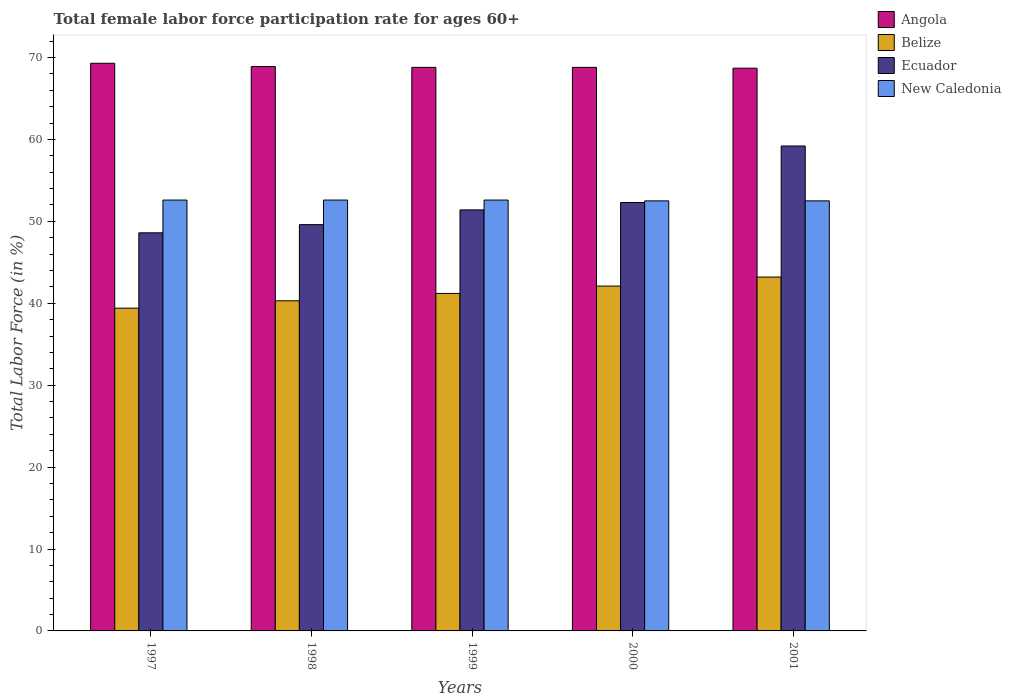How many different coloured bars are there?
Your response must be concise. 4. What is the label of the 1st group of bars from the left?
Your response must be concise. 1997. In how many cases, is the number of bars for a given year not equal to the number of legend labels?
Your answer should be compact. 0. What is the female labor force participation rate in Angola in 1999?
Offer a very short reply. 68.8. Across all years, what is the maximum female labor force participation rate in New Caledonia?
Your response must be concise. 52.6. Across all years, what is the minimum female labor force participation rate in Belize?
Provide a short and direct response. 39.4. In which year was the female labor force participation rate in Belize maximum?
Offer a terse response. 2001. What is the total female labor force participation rate in Angola in the graph?
Make the answer very short. 344.5. What is the difference between the female labor force participation rate in Belize in 1997 and that in 2000?
Ensure brevity in your answer.  -2.7. What is the difference between the female labor force participation rate in Ecuador in 2000 and the female labor force participation rate in Belize in 1999?
Provide a short and direct response. 11.1. What is the average female labor force participation rate in New Caledonia per year?
Make the answer very short. 52.56. In the year 2000, what is the difference between the female labor force participation rate in Belize and female labor force participation rate in Angola?
Make the answer very short. -26.7. What is the ratio of the female labor force participation rate in New Caledonia in 1997 to that in 2001?
Provide a short and direct response. 1. Is the female labor force participation rate in Ecuador in 1998 less than that in 2000?
Offer a very short reply. Yes. What is the difference between the highest and the second highest female labor force participation rate in Ecuador?
Provide a succinct answer. 6.9. What is the difference between the highest and the lowest female labor force participation rate in Ecuador?
Provide a succinct answer. 10.6. Is the sum of the female labor force participation rate in Belize in 1998 and 1999 greater than the maximum female labor force participation rate in New Caledonia across all years?
Give a very brief answer. Yes. Is it the case that in every year, the sum of the female labor force participation rate in Belize and female labor force participation rate in New Caledonia is greater than the sum of female labor force participation rate in Ecuador and female labor force participation rate in Angola?
Give a very brief answer. No. What does the 4th bar from the left in 1999 represents?
Offer a terse response. New Caledonia. What does the 3rd bar from the right in 1997 represents?
Offer a very short reply. Belize. Is it the case that in every year, the sum of the female labor force participation rate in Ecuador and female labor force participation rate in New Caledonia is greater than the female labor force participation rate in Angola?
Provide a short and direct response. Yes. Are all the bars in the graph horizontal?
Offer a terse response. No. How many years are there in the graph?
Your answer should be very brief. 5. Are the values on the major ticks of Y-axis written in scientific E-notation?
Provide a succinct answer. No. Does the graph contain grids?
Your answer should be very brief. No. How many legend labels are there?
Make the answer very short. 4. How are the legend labels stacked?
Offer a terse response. Vertical. What is the title of the graph?
Provide a short and direct response. Total female labor force participation rate for ages 60+. What is the Total Labor Force (in %) in Angola in 1997?
Provide a short and direct response. 69.3. What is the Total Labor Force (in %) of Belize in 1997?
Offer a terse response. 39.4. What is the Total Labor Force (in %) of Ecuador in 1997?
Give a very brief answer. 48.6. What is the Total Labor Force (in %) of New Caledonia in 1997?
Your answer should be very brief. 52.6. What is the Total Labor Force (in %) in Angola in 1998?
Your answer should be very brief. 68.9. What is the Total Labor Force (in %) of Belize in 1998?
Give a very brief answer. 40.3. What is the Total Labor Force (in %) in Ecuador in 1998?
Offer a very short reply. 49.6. What is the Total Labor Force (in %) in New Caledonia in 1998?
Your answer should be very brief. 52.6. What is the Total Labor Force (in %) in Angola in 1999?
Offer a very short reply. 68.8. What is the Total Labor Force (in %) in Belize in 1999?
Your response must be concise. 41.2. What is the Total Labor Force (in %) in Ecuador in 1999?
Offer a terse response. 51.4. What is the Total Labor Force (in %) in New Caledonia in 1999?
Make the answer very short. 52.6. What is the Total Labor Force (in %) in Angola in 2000?
Your answer should be compact. 68.8. What is the Total Labor Force (in %) of Belize in 2000?
Ensure brevity in your answer.  42.1. What is the Total Labor Force (in %) in Ecuador in 2000?
Your answer should be compact. 52.3. What is the Total Labor Force (in %) in New Caledonia in 2000?
Offer a terse response. 52.5. What is the Total Labor Force (in %) of Angola in 2001?
Provide a succinct answer. 68.7. What is the Total Labor Force (in %) in Belize in 2001?
Make the answer very short. 43.2. What is the Total Labor Force (in %) of Ecuador in 2001?
Offer a terse response. 59.2. What is the Total Labor Force (in %) of New Caledonia in 2001?
Your answer should be very brief. 52.5. Across all years, what is the maximum Total Labor Force (in %) in Angola?
Offer a very short reply. 69.3. Across all years, what is the maximum Total Labor Force (in %) in Belize?
Provide a succinct answer. 43.2. Across all years, what is the maximum Total Labor Force (in %) in Ecuador?
Your answer should be very brief. 59.2. Across all years, what is the maximum Total Labor Force (in %) in New Caledonia?
Give a very brief answer. 52.6. Across all years, what is the minimum Total Labor Force (in %) of Angola?
Ensure brevity in your answer.  68.7. Across all years, what is the minimum Total Labor Force (in %) of Belize?
Offer a terse response. 39.4. Across all years, what is the minimum Total Labor Force (in %) of Ecuador?
Provide a succinct answer. 48.6. Across all years, what is the minimum Total Labor Force (in %) of New Caledonia?
Provide a succinct answer. 52.5. What is the total Total Labor Force (in %) in Angola in the graph?
Ensure brevity in your answer.  344.5. What is the total Total Labor Force (in %) of Belize in the graph?
Give a very brief answer. 206.2. What is the total Total Labor Force (in %) in Ecuador in the graph?
Provide a short and direct response. 261.1. What is the total Total Labor Force (in %) in New Caledonia in the graph?
Your response must be concise. 262.8. What is the difference between the Total Labor Force (in %) of Belize in 1997 and that in 1998?
Make the answer very short. -0.9. What is the difference between the Total Labor Force (in %) of Ecuador in 1997 and that in 1998?
Your response must be concise. -1. What is the difference between the Total Labor Force (in %) of New Caledonia in 1997 and that in 1998?
Provide a short and direct response. 0. What is the difference between the Total Labor Force (in %) in Angola in 1997 and that in 1999?
Offer a very short reply. 0.5. What is the difference between the Total Labor Force (in %) in Belize in 1997 and that in 1999?
Give a very brief answer. -1.8. What is the difference between the Total Labor Force (in %) in New Caledonia in 1997 and that in 1999?
Offer a very short reply. 0. What is the difference between the Total Labor Force (in %) in Angola in 1997 and that in 2000?
Offer a very short reply. 0.5. What is the difference between the Total Labor Force (in %) of Ecuador in 1997 and that in 2000?
Provide a succinct answer. -3.7. What is the difference between the Total Labor Force (in %) of Angola in 1997 and that in 2001?
Provide a succinct answer. 0.6. What is the difference between the Total Labor Force (in %) in Belize in 1997 and that in 2001?
Ensure brevity in your answer.  -3.8. What is the difference between the Total Labor Force (in %) of New Caledonia in 1997 and that in 2001?
Offer a terse response. 0.1. What is the difference between the Total Labor Force (in %) of Angola in 1998 and that in 1999?
Ensure brevity in your answer.  0.1. What is the difference between the Total Labor Force (in %) of Belize in 1998 and that in 1999?
Make the answer very short. -0.9. What is the difference between the Total Labor Force (in %) of New Caledonia in 1998 and that in 1999?
Offer a very short reply. 0. What is the difference between the Total Labor Force (in %) in Angola in 1998 and that in 2000?
Make the answer very short. 0.1. What is the difference between the Total Labor Force (in %) in Belize in 1998 and that in 2000?
Give a very brief answer. -1.8. What is the difference between the Total Labor Force (in %) in Ecuador in 1998 and that in 2000?
Offer a very short reply. -2.7. What is the difference between the Total Labor Force (in %) in New Caledonia in 1998 and that in 2000?
Provide a succinct answer. 0.1. What is the difference between the Total Labor Force (in %) in Angola in 1998 and that in 2001?
Provide a succinct answer. 0.2. What is the difference between the Total Labor Force (in %) of Belize in 1999 and that in 2000?
Your answer should be compact. -0.9. What is the difference between the Total Labor Force (in %) of Angola in 1999 and that in 2001?
Your answer should be compact. 0.1. What is the difference between the Total Labor Force (in %) in Angola in 2000 and that in 2001?
Provide a succinct answer. 0.1. What is the difference between the Total Labor Force (in %) in Ecuador in 2000 and that in 2001?
Your response must be concise. -6.9. What is the difference between the Total Labor Force (in %) of Angola in 1997 and the Total Labor Force (in %) of Belize in 1998?
Offer a very short reply. 29. What is the difference between the Total Labor Force (in %) in Angola in 1997 and the Total Labor Force (in %) in New Caledonia in 1998?
Provide a short and direct response. 16.7. What is the difference between the Total Labor Force (in %) in Angola in 1997 and the Total Labor Force (in %) in Belize in 1999?
Offer a terse response. 28.1. What is the difference between the Total Labor Force (in %) of Angola in 1997 and the Total Labor Force (in %) of Ecuador in 1999?
Your response must be concise. 17.9. What is the difference between the Total Labor Force (in %) of Angola in 1997 and the Total Labor Force (in %) of New Caledonia in 1999?
Ensure brevity in your answer.  16.7. What is the difference between the Total Labor Force (in %) in Belize in 1997 and the Total Labor Force (in %) in Ecuador in 1999?
Ensure brevity in your answer.  -12. What is the difference between the Total Labor Force (in %) of Ecuador in 1997 and the Total Labor Force (in %) of New Caledonia in 1999?
Provide a short and direct response. -4. What is the difference between the Total Labor Force (in %) of Angola in 1997 and the Total Labor Force (in %) of Belize in 2000?
Provide a short and direct response. 27.2. What is the difference between the Total Labor Force (in %) of Angola in 1997 and the Total Labor Force (in %) of New Caledonia in 2000?
Offer a very short reply. 16.8. What is the difference between the Total Labor Force (in %) of Belize in 1997 and the Total Labor Force (in %) of Ecuador in 2000?
Provide a succinct answer. -12.9. What is the difference between the Total Labor Force (in %) in Angola in 1997 and the Total Labor Force (in %) in Belize in 2001?
Offer a terse response. 26.1. What is the difference between the Total Labor Force (in %) in Angola in 1997 and the Total Labor Force (in %) in New Caledonia in 2001?
Keep it short and to the point. 16.8. What is the difference between the Total Labor Force (in %) in Belize in 1997 and the Total Labor Force (in %) in Ecuador in 2001?
Provide a succinct answer. -19.8. What is the difference between the Total Labor Force (in %) of Ecuador in 1997 and the Total Labor Force (in %) of New Caledonia in 2001?
Provide a short and direct response. -3.9. What is the difference between the Total Labor Force (in %) of Angola in 1998 and the Total Labor Force (in %) of Belize in 1999?
Your answer should be very brief. 27.7. What is the difference between the Total Labor Force (in %) in Belize in 1998 and the Total Labor Force (in %) in Ecuador in 1999?
Your response must be concise. -11.1. What is the difference between the Total Labor Force (in %) of Ecuador in 1998 and the Total Labor Force (in %) of New Caledonia in 1999?
Your answer should be compact. -3. What is the difference between the Total Labor Force (in %) in Angola in 1998 and the Total Labor Force (in %) in Belize in 2000?
Provide a succinct answer. 26.8. What is the difference between the Total Labor Force (in %) in Angola in 1998 and the Total Labor Force (in %) in Ecuador in 2000?
Your response must be concise. 16.6. What is the difference between the Total Labor Force (in %) in Angola in 1998 and the Total Labor Force (in %) in New Caledonia in 2000?
Your response must be concise. 16.4. What is the difference between the Total Labor Force (in %) in Belize in 1998 and the Total Labor Force (in %) in Ecuador in 2000?
Make the answer very short. -12. What is the difference between the Total Labor Force (in %) in Belize in 1998 and the Total Labor Force (in %) in New Caledonia in 2000?
Make the answer very short. -12.2. What is the difference between the Total Labor Force (in %) in Ecuador in 1998 and the Total Labor Force (in %) in New Caledonia in 2000?
Keep it short and to the point. -2.9. What is the difference between the Total Labor Force (in %) in Angola in 1998 and the Total Labor Force (in %) in Belize in 2001?
Provide a short and direct response. 25.7. What is the difference between the Total Labor Force (in %) in Angola in 1998 and the Total Labor Force (in %) in New Caledonia in 2001?
Your answer should be compact. 16.4. What is the difference between the Total Labor Force (in %) in Belize in 1998 and the Total Labor Force (in %) in Ecuador in 2001?
Offer a terse response. -18.9. What is the difference between the Total Labor Force (in %) of Belize in 1998 and the Total Labor Force (in %) of New Caledonia in 2001?
Your response must be concise. -12.2. What is the difference between the Total Labor Force (in %) in Angola in 1999 and the Total Labor Force (in %) in Belize in 2000?
Provide a short and direct response. 26.7. What is the difference between the Total Labor Force (in %) of Angola in 1999 and the Total Labor Force (in %) of Ecuador in 2000?
Make the answer very short. 16.5. What is the difference between the Total Labor Force (in %) of Belize in 1999 and the Total Labor Force (in %) of Ecuador in 2000?
Ensure brevity in your answer.  -11.1. What is the difference between the Total Labor Force (in %) in Ecuador in 1999 and the Total Labor Force (in %) in New Caledonia in 2000?
Keep it short and to the point. -1.1. What is the difference between the Total Labor Force (in %) of Angola in 1999 and the Total Labor Force (in %) of Belize in 2001?
Make the answer very short. 25.6. What is the difference between the Total Labor Force (in %) of Angola in 1999 and the Total Labor Force (in %) of Ecuador in 2001?
Offer a terse response. 9.6. What is the difference between the Total Labor Force (in %) in Angola in 1999 and the Total Labor Force (in %) in New Caledonia in 2001?
Provide a short and direct response. 16.3. What is the difference between the Total Labor Force (in %) in Belize in 1999 and the Total Labor Force (in %) in New Caledonia in 2001?
Give a very brief answer. -11.3. What is the difference between the Total Labor Force (in %) of Ecuador in 1999 and the Total Labor Force (in %) of New Caledonia in 2001?
Your answer should be very brief. -1.1. What is the difference between the Total Labor Force (in %) in Angola in 2000 and the Total Labor Force (in %) in Belize in 2001?
Provide a short and direct response. 25.6. What is the difference between the Total Labor Force (in %) of Angola in 2000 and the Total Labor Force (in %) of Ecuador in 2001?
Offer a terse response. 9.6. What is the difference between the Total Labor Force (in %) of Angola in 2000 and the Total Labor Force (in %) of New Caledonia in 2001?
Give a very brief answer. 16.3. What is the difference between the Total Labor Force (in %) of Belize in 2000 and the Total Labor Force (in %) of Ecuador in 2001?
Provide a succinct answer. -17.1. What is the difference between the Total Labor Force (in %) in Belize in 2000 and the Total Labor Force (in %) in New Caledonia in 2001?
Provide a short and direct response. -10.4. What is the average Total Labor Force (in %) in Angola per year?
Your response must be concise. 68.9. What is the average Total Labor Force (in %) of Belize per year?
Provide a succinct answer. 41.24. What is the average Total Labor Force (in %) of Ecuador per year?
Your answer should be very brief. 52.22. What is the average Total Labor Force (in %) in New Caledonia per year?
Your answer should be compact. 52.56. In the year 1997, what is the difference between the Total Labor Force (in %) of Angola and Total Labor Force (in %) of Belize?
Your answer should be very brief. 29.9. In the year 1997, what is the difference between the Total Labor Force (in %) in Angola and Total Labor Force (in %) in Ecuador?
Your answer should be very brief. 20.7. In the year 1997, what is the difference between the Total Labor Force (in %) of Angola and Total Labor Force (in %) of New Caledonia?
Your answer should be compact. 16.7. In the year 1997, what is the difference between the Total Labor Force (in %) of Belize and Total Labor Force (in %) of Ecuador?
Your response must be concise. -9.2. In the year 1997, what is the difference between the Total Labor Force (in %) in Belize and Total Labor Force (in %) in New Caledonia?
Keep it short and to the point. -13.2. In the year 1998, what is the difference between the Total Labor Force (in %) in Angola and Total Labor Force (in %) in Belize?
Make the answer very short. 28.6. In the year 1998, what is the difference between the Total Labor Force (in %) of Angola and Total Labor Force (in %) of Ecuador?
Make the answer very short. 19.3. In the year 1998, what is the difference between the Total Labor Force (in %) of Angola and Total Labor Force (in %) of New Caledonia?
Ensure brevity in your answer.  16.3. In the year 1998, what is the difference between the Total Labor Force (in %) in Belize and Total Labor Force (in %) in Ecuador?
Offer a terse response. -9.3. In the year 1998, what is the difference between the Total Labor Force (in %) of Belize and Total Labor Force (in %) of New Caledonia?
Your answer should be very brief. -12.3. In the year 1999, what is the difference between the Total Labor Force (in %) of Angola and Total Labor Force (in %) of Belize?
Your answer should be very brief. 27.6. In the year 1999, what is the difference between the Total Labor Force (in %) in Angola and Total Labor Force (in %) in New Caledonia?
Offer a terse response. 16.2. In the year 2000, what is the difference between the Total Labor Force (in %) of Angola and Total Labor Force (in %) of Belize?
Give a very brief answer. 26.7. In the year 2000, what is the difference between the Total Labor Force (in %) in Angola and Total Labor Force (in %) in Ecuador?
Ensure brevity in your answer.  16.5. In the year 2000, what is the difference between the Total Labor Force (in %) in Angola and Total Labor Force (in %) in New Caledonia?
Provide a short and direct response. 16.3. In the year 2000, what is the difference between the Total Labor Force (in %) in Belize and Total Labor Force (in %) in New Caledonia?
Offer a terse response. -10.4. In the year 2000, what is the difference between the Total Labor Force (in %) of Ecuador and Total Labor Force (in %) of New Caledonia?
Make the answer very short. -0.2. In the year 2001, what is the difference between the Total Labor Force (in %) in Angola and Total Labor Force (in %) in Belize?
Provide a succinct answer. 25.5. In the year 2001, what is the difference between the Total Labor Force (in %) of Angola and Total Labor Force (in %) of Ecuador?
Make the answer very short. 9.5. In the year 2001, what is the difference between the Total Labor Force (in %) of Belize and Total Labor Force (in %) of Ecuador?
Provide a short and direct response. -16. In the year 2001, what is the difference between the Total Labor Force (in %) in Belize and Total Labor Force (in %) in New Caledonia?
Ensure brevity in your answer.  -9.3. What is the ratio of the Total Labor Force (in %) of Belize in 1997 to that in 1998?
Your response must be concise. 0.98. What is the ratio of the Total Labor Force (in %) in Ecuador in 1997 to that in 1998?
Ensure brevity in your answer.  0.98. What is the ratio of the Total Labor Force (in %) of New Caledonia in 1997 to that in 1998?
Give a very brief answer. 1. What is the ratio of the Total Labor Force (in %) in Angola in 1997 to that in 1999?
Provide a succinct answer. 1.01. What is the ratio of the Total Labor Force (in %) in Belize in 1997 to that in 1999?
Ensure brevity in your answer.  0.96. What is the ratio of the Total Labor Force (in %) in Ecuador in 1997 to that in 1999?
Make the answer very short. 0.95. What is the ratio of the Total Labor Force (in %) of Angola in 1997 to that in 2000?
Provide a succinct answer. 1.01. What is the ratio of the Total Labor Force (in %) of Belize in 1997 to that in 2000?
Your answer should be very brief. 0.94. What is the ratio of the Total Labor Force (in %) in Ecuador in 1997 to that in 2000?
Provide a succinct answer. 0.93. What is the ratio of the Total Labor Force (in %) in Angola in 1997 to that in 2001?
Provide a short and direct response. 1.01. What is the ratio of the Total Labor Force (in %) of Belize in 1997 to that in 2001?
Ensure brevity in your answer.  0.91. What is the ratio of the Total Labor Force (in %) in Ecuador in 1997 to that in 2001?
Offer a terse response. 0.82. What is the ratio of the Total Labor Force (in %) of New Caledonia in 1997 to that in 2001?
Keep it short and to the point. 1. What is the ratio of the Total Labor Force (in %) of Angola in 1998 to that in 1999?
Provide a succinct answer. 1. What is the ratio of the Total Labor Force (in %) of Belize in 1998 to that in 1999?
Ensure brevity in your answer.  0.98. What is the ratio of the Total Labor Force (in %) of Ecuador in 1998 to that in 1999?
Provide a succinct answer. 0.96. What is the ratio of the Total Labor Force (in %) of Belize in 1998 to that in 2000?
Ensure brevity in your answer.  0.96. What is the ratio of the Total Labor Force (in %) in Ecuador in 1998 to that in 2000?
Give a very brief answer. 0.95. What is the ratio of the Total Labor Force (in %) in Angola in 1998 to that in 2001?
Ensure brevity in your answer.  1. What is the ratio of the Total Labor Force (in %) in Belize in 1998 to that in 2001?
Provide a succinct answer. 0.93. What is the ratio of the Total Labor Force (in %) in Ecuador in 1998 to that in 2001?
Your response must be concise. 0.84. What is the ratio of the Total Labor Force (in %) of New Caledonia in 1998 to that in 2001?
Offer a terse response. 1. What is the ratio of the Total Labor Force (in %) in Angola in 1999 to that in 2000?
Offer a very short reply. 1. What is the ratio of the Total Labor Force (in %) of Belize in 1999 to that in 2000?
Offer a very short reply. 0.98. What is the ratio of the Total Labor Force (in %) of Ecuador in 1999 to that in 2000?
Your response must be concise. 0.98. What is the ratio of the Total Labor Force (in %) in New Caledonia in 1999 to that in 2000?
Your response must be concise. 1. What is the ratio of the Total Labor Force (in %) in Angola in 1999 to that in 2001?
Offer a very short reply. 1. What is the ratio of the Total Labor Force (in %) of Belize in 1999 to that in 2001?
Your response must be concise. 0.95. What is the ratio of the Total Labor Force (in %) in Ecuador in 1999 to that in 2001?
Ensure brevity in your answer.  0.87. What is the ratio of the Total Labor Force (in %) of New Caledonia in 1999 to that in 2001?
Your answer should be compact. 1. What is the ratio of the Total Labor Force (in %) of Angola in 2000 to that in 2001?
Keep it short and to the point. 1. What is the ratio of the Total Labor Force (in %) in Belize in 2000 to that in 2001?
Your answer should be very brief. 0.97. What is the ratio of the Total Labor Force (in %) of Ecuador in 2000 to that in 2001?
Provide a succinct answer. 0.88. What is the difference between the highest and the second highest Total Labor Force (in %) of New Caledonia?
Give a very brief answer. 0. 